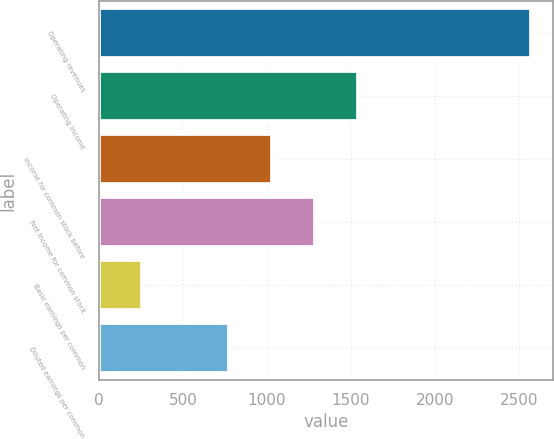Convert chart. <chart><loc_0><loc_0><loc_500><loc_500><bar_chart><fcel>Operating revenues<fcel>Operating income<fcel>Income for common stock before<fcel>Net income for common stock<fcel>Basic earnings per common<fcel>Diluted earnings per common<nl><fcel>2571<fcel>1542.9<fcel>1028.84<fcel>1285.87<fcel>257.75<fcel>771.81<nl></chart> 